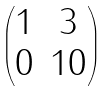Convert formula to latex. <formula><loc_0><loc_0><loc_500><loc_500>\begin{pmatrix} 1 & 3 \\ 0 & 1 0 \end{pmatrix}</formula> 